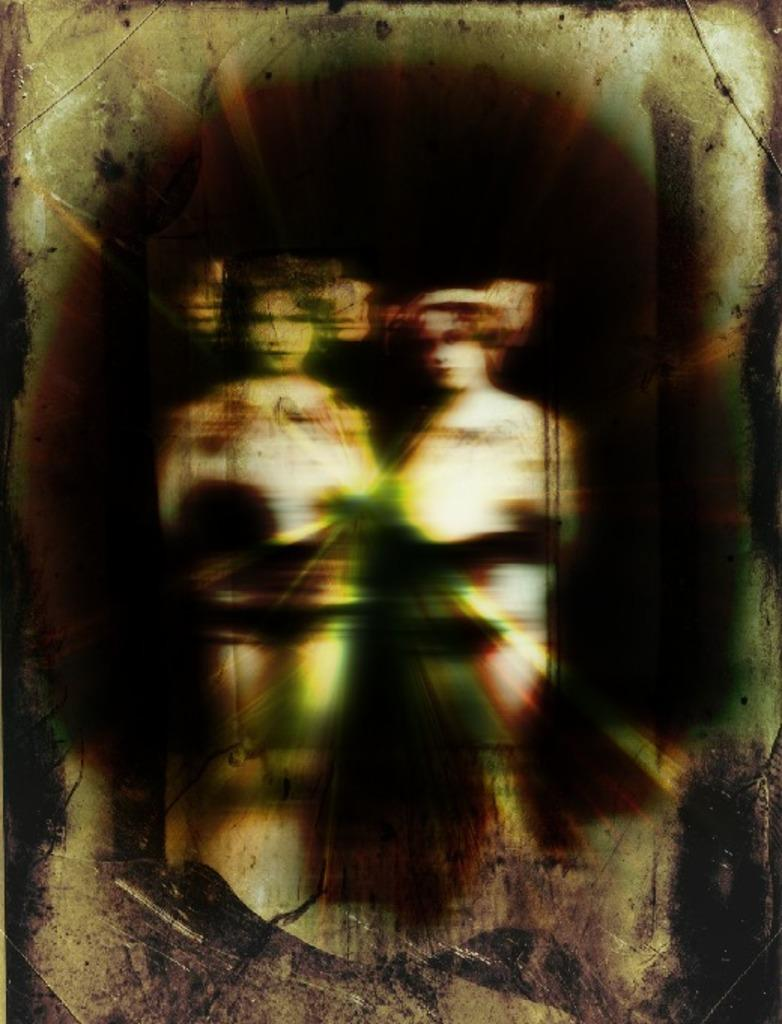What object is present in the image that typically holds a photograph? There is a photo frame in the image. How many people are depicted in the photo frame? The photo frame contains two persons. How many bikes are parked next to the photo frame in the image? There are no bikes present in the image; it only features a photo frame with two persons. What type of jam is being spread on the photo frame in the image? There is no jam present in the image, as it only features a photo frame with two persons. 